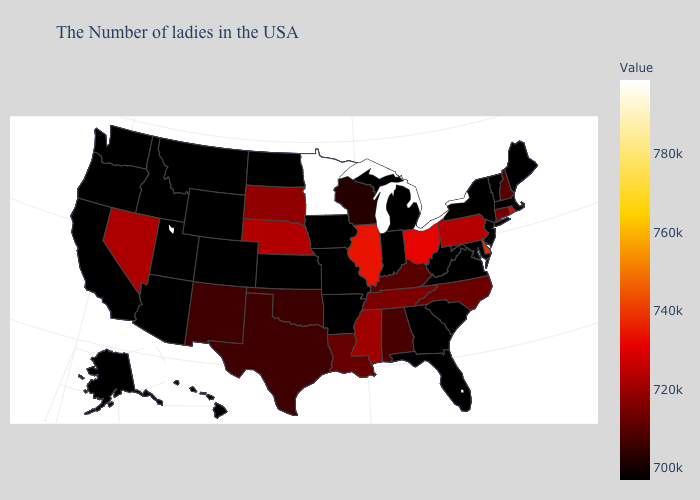Which states hav the highest value in the MidWest?
Short answer required. Minnesota. Which states have the lowest value in the South?
Keep it brief. Maryland, Virginia, South Carolina, West Virginia, Florida, Georgia, Arkansas. Does Wisconsin have the lowest value in the USA?
Short answer required. No. Which states have the lowest value in the MidWest?
Answer briefly. Michigan, Indiana, Missouri, Iowa, Kansas, North Dakota. Which states hav the highest value in the South?
Quick response, please. Delaware. Which states have the highest value in the USA?
Write a very short answer. Minnesota. Which states have the lowest value in the MidWest?
Write a very short answer. Michigan, Indiana, Missouri, Iowa, Kansas, North Dakota. 